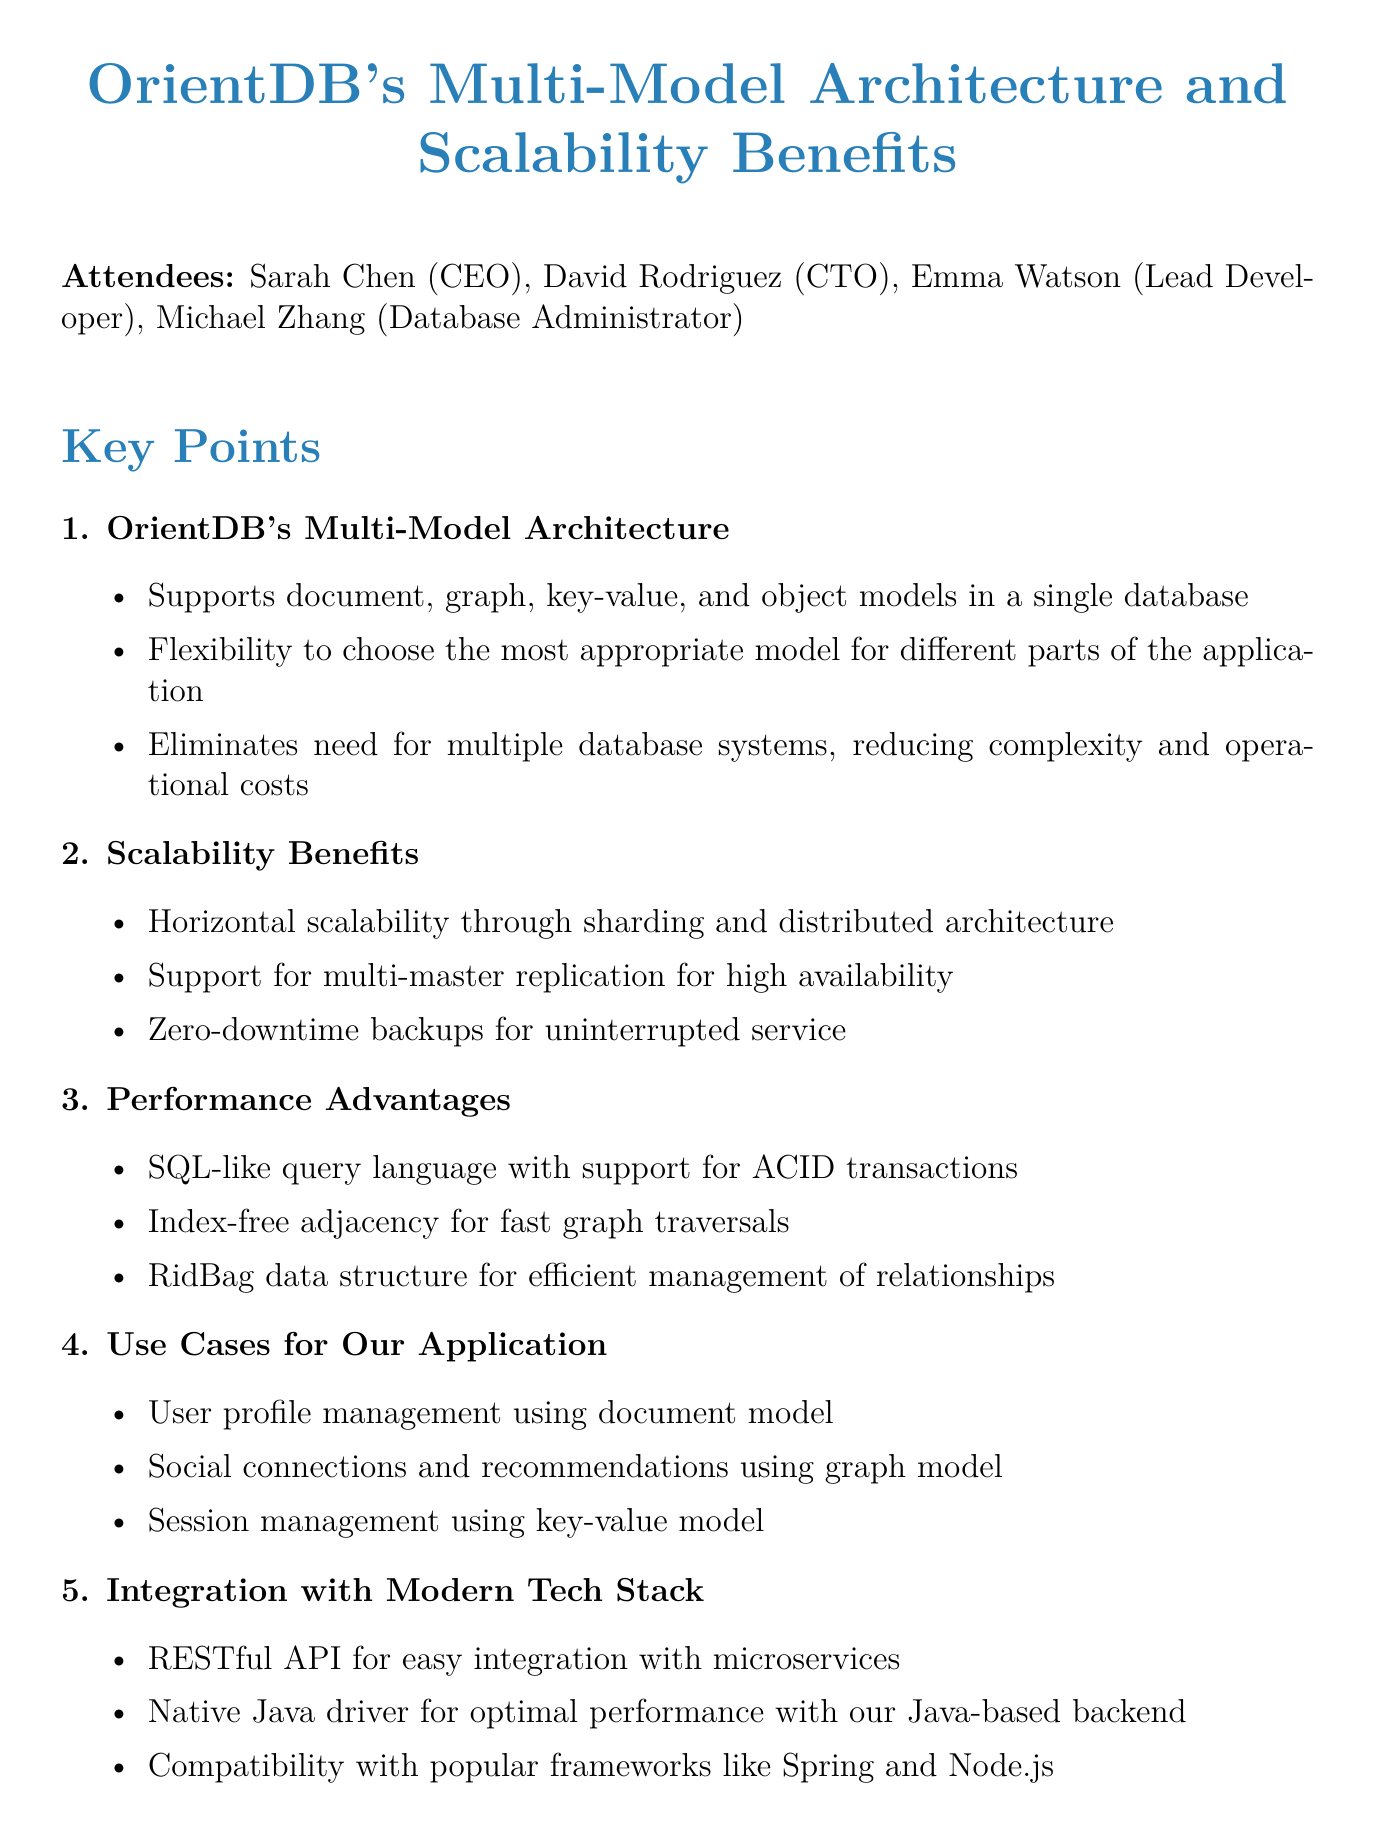What are the attendees' names? The attendees' names are listed in the document, which includes the CEO, CTO, Lead Developer, and Database Administrator.
Answer: Sarah Chen, David Rodriguez, Emma Watson, Michael Zhang What is one benefit of OrientDB's multi-model architecture? The document outlines several benefits of OrientDB's multi-model architecture, such as flexibility and reduced complexity.
Answer: Flexibility to choose the most appropriate model What is the total number of key points discussed? The document lists five distinct key points related to the multi-model architecture and scalability benefits of OrientDB.
Answer: Five What action item is assigned to Emma? The document specifies the action items and who they are assigned to, detailing what each team member needs to do.
Answer: Create a proof-of-concept What is the next step after the meeting? The document mentions reviewing findings and making a decision regarding the database migration as the subsequent step.
Answer: Review findings in two weeks What type of replication does OrientDB support? The document explicitly states that OrientDB supports a specific type of replication for high availability as one of its benefits.
Answer: Multi-master replication Which model will be used for session management in our application? The document presents specific use cases for the application, detailing which models will be utilized for various functionalities.
Answer: Key-value model What API does OrientDB provide for integration? The document highlights the integration capabilities of OrientDB and mentions a specific type of API for this purpose.
Answer: RESTful API 